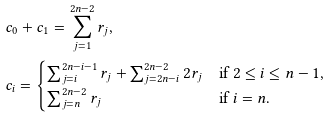Convert formula to latex. <formula><loc_0><loc_0><loc_500><loc_500>& c _ { 0 } + c _ { 1 } = \sum _ { j = 1 } ^ { 2 n - 2 } r _ { j } , \\ & c _ { i } = \begin{cases} \sum _ { j = i } ^ { 2 n - i - 1 } r _ { j } + \sum _ { j = 2 n - i } ^ { 2 n - 2 } 2 r _ { j } & \text {if $2\leq i \leq n-1$} , \\ \sum _ { j = n } ^ { 2 n - 2 } r _ { j } & \text {if $i=n$} . \end{cases}</formula> 